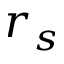<formula> <loc_0><loc_0><loc_500><loc_500>r _ { s }</formula> 